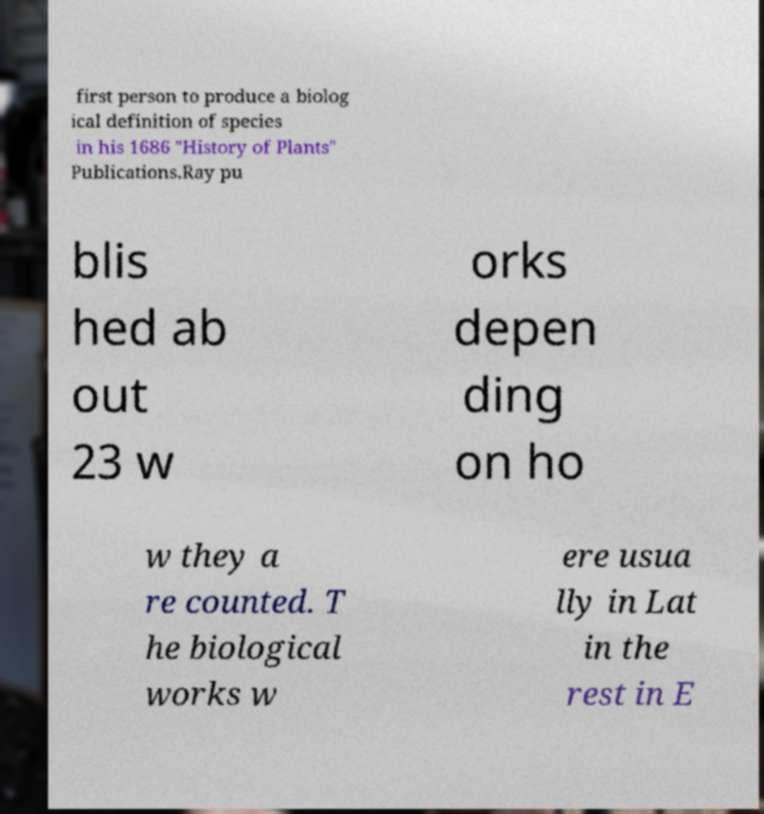What messages or text are displayed in this image? I need them in a readable, typed format. first person to produce a biolog ical definition of species in his 1686 "History of Plants" Publications.Ray pu blis hed ab out 23 w orks depen ding on ho w they a re counted. T he biological works w ere usua lly in Lat in the rest in E 